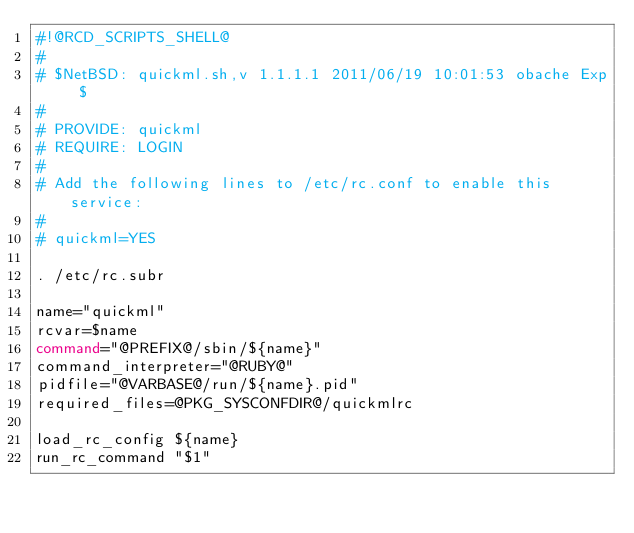<code> <loc_0><loc_0><loc_500><loc_500><_Bash_>#!@RCD_SCRIPTS_SHELL@
#
# $NetBSD: quickml.sh,v 1.1.1.1 2011/06/19 10:01:53 obache Exp $
#
# PROVIDE: quickml
# REQUIRE: LOGIN
#
# Add the following lines to /etc/rc.conf to enable this service:
#
# quickml=YES

. /etc/rc.subr

name="quickml"
rcvar=$name
command="@PREFIX@/sbin/${name}"
command_interpreter="@RUBY@"
pidfile="@VARBASE@/run/${name}.pid"
required_files=@PKG_SYSCONFDIR@/quickmlrc

load_rc_config ${name}
run_rc_command "$1"
</code> 